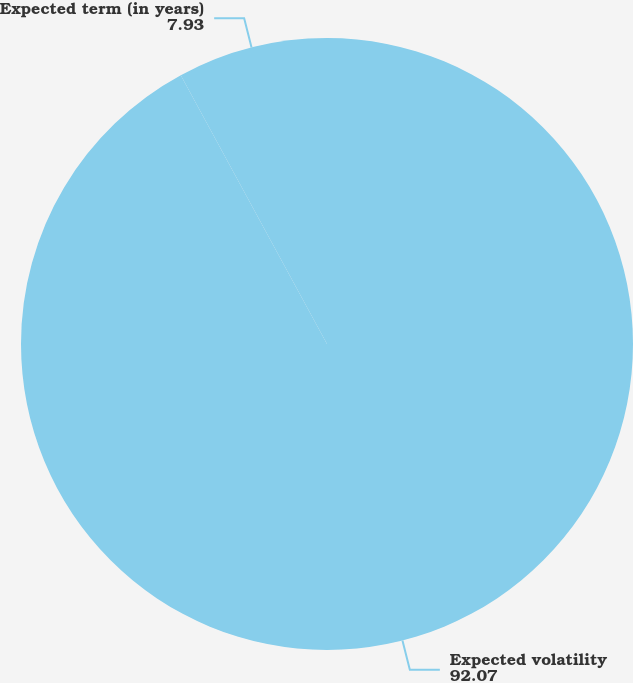<chart> <loc_0><loc_0><loc_500><loc_500><pie_chart><fcel>Expected volatility<fcel>Expected term (in years)<nl><fcel>92.07%<fcel>7.93%<nl></chart> 